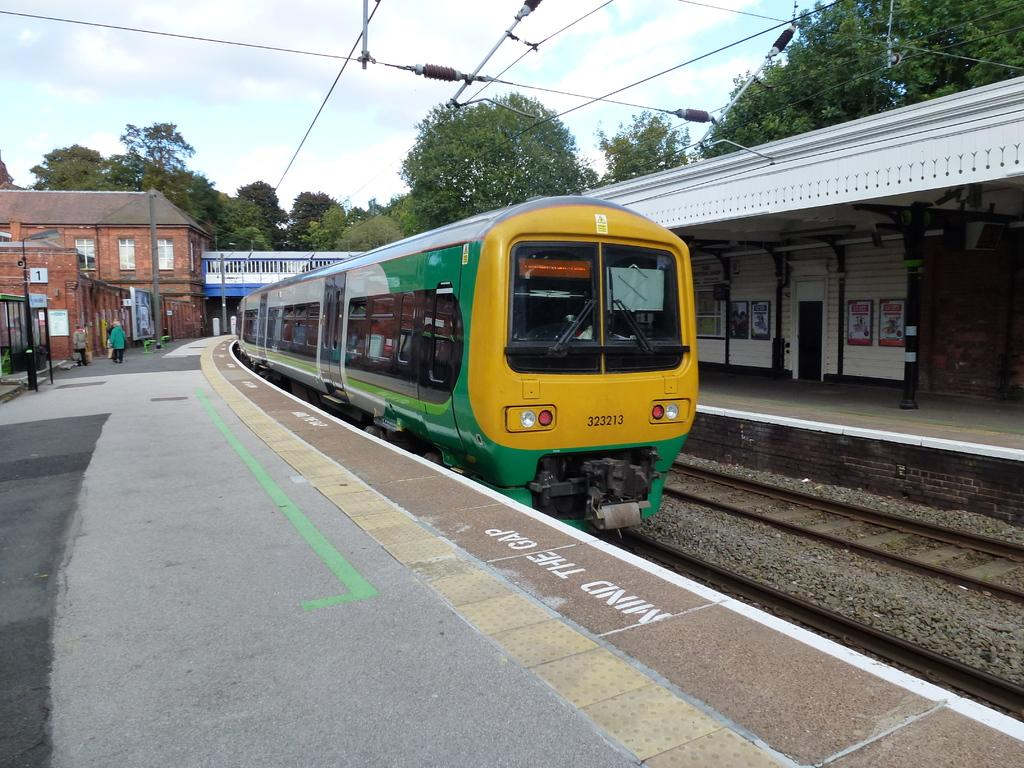<image>
Relay a brief, clear account of the picture shown. A train pulls into a station while passengers are reminded to mind the gap. 